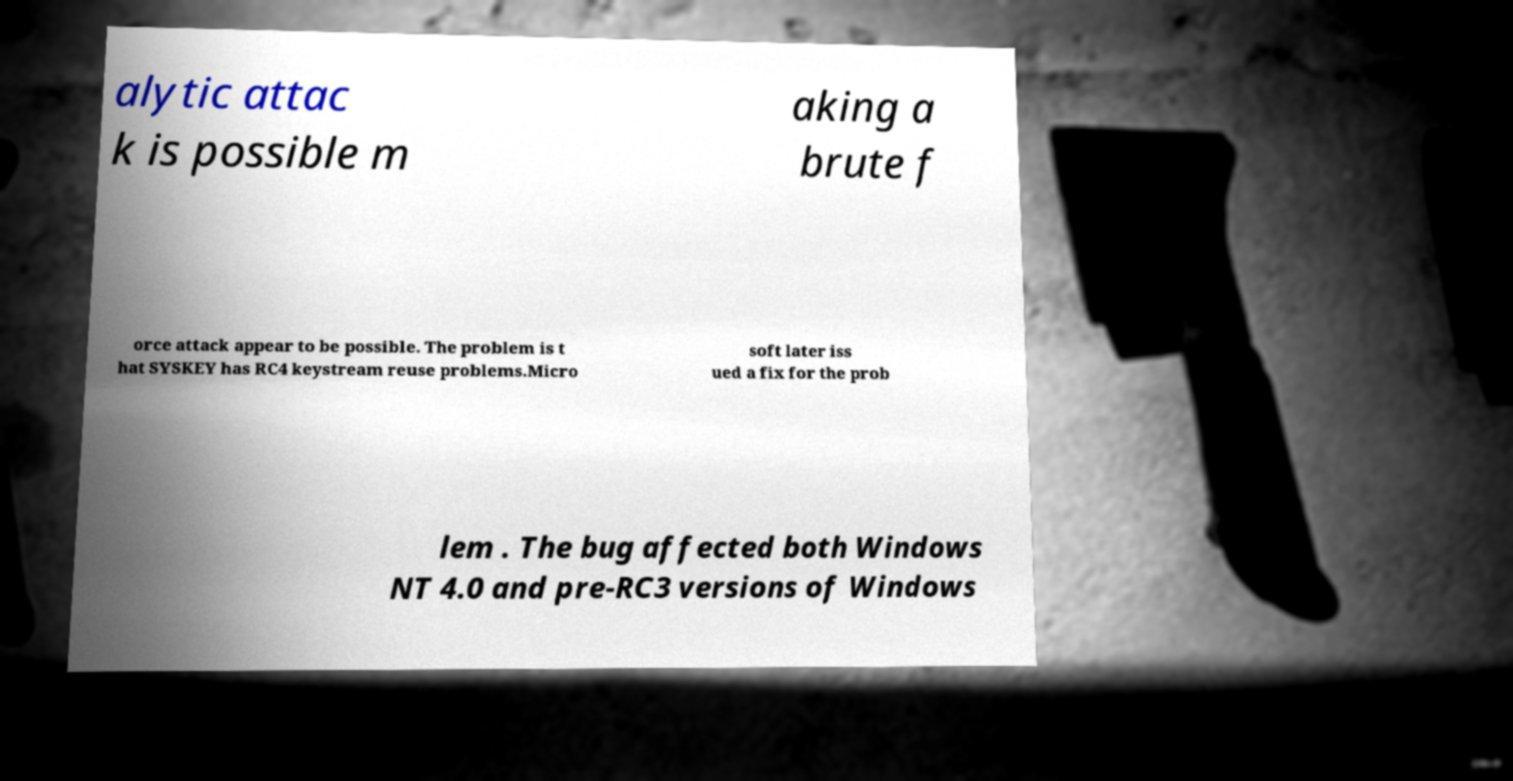Could you assist in decoding the text presented in this image and type it out clearly? alytic attac k is possible m aking a brute f orce attack appear to be possible. The problem is t hat SYSKEY has RC4 keystream reuse problems.Micro soft later iss ued a fix for the prob lem . The bug affected both Windows NT 4.0 and pre-RC3 versions of Windows 